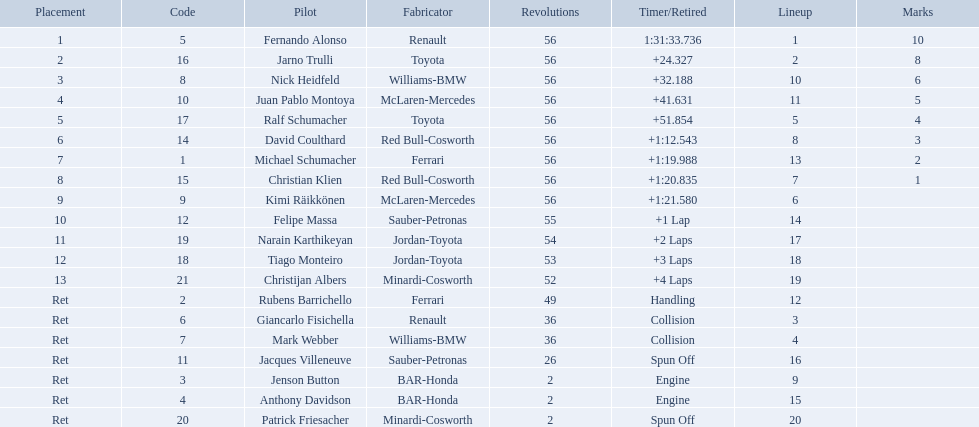What place did fernando alonso finish? 1. How long did it take alonso to finish the race? 1:31:33.736. 